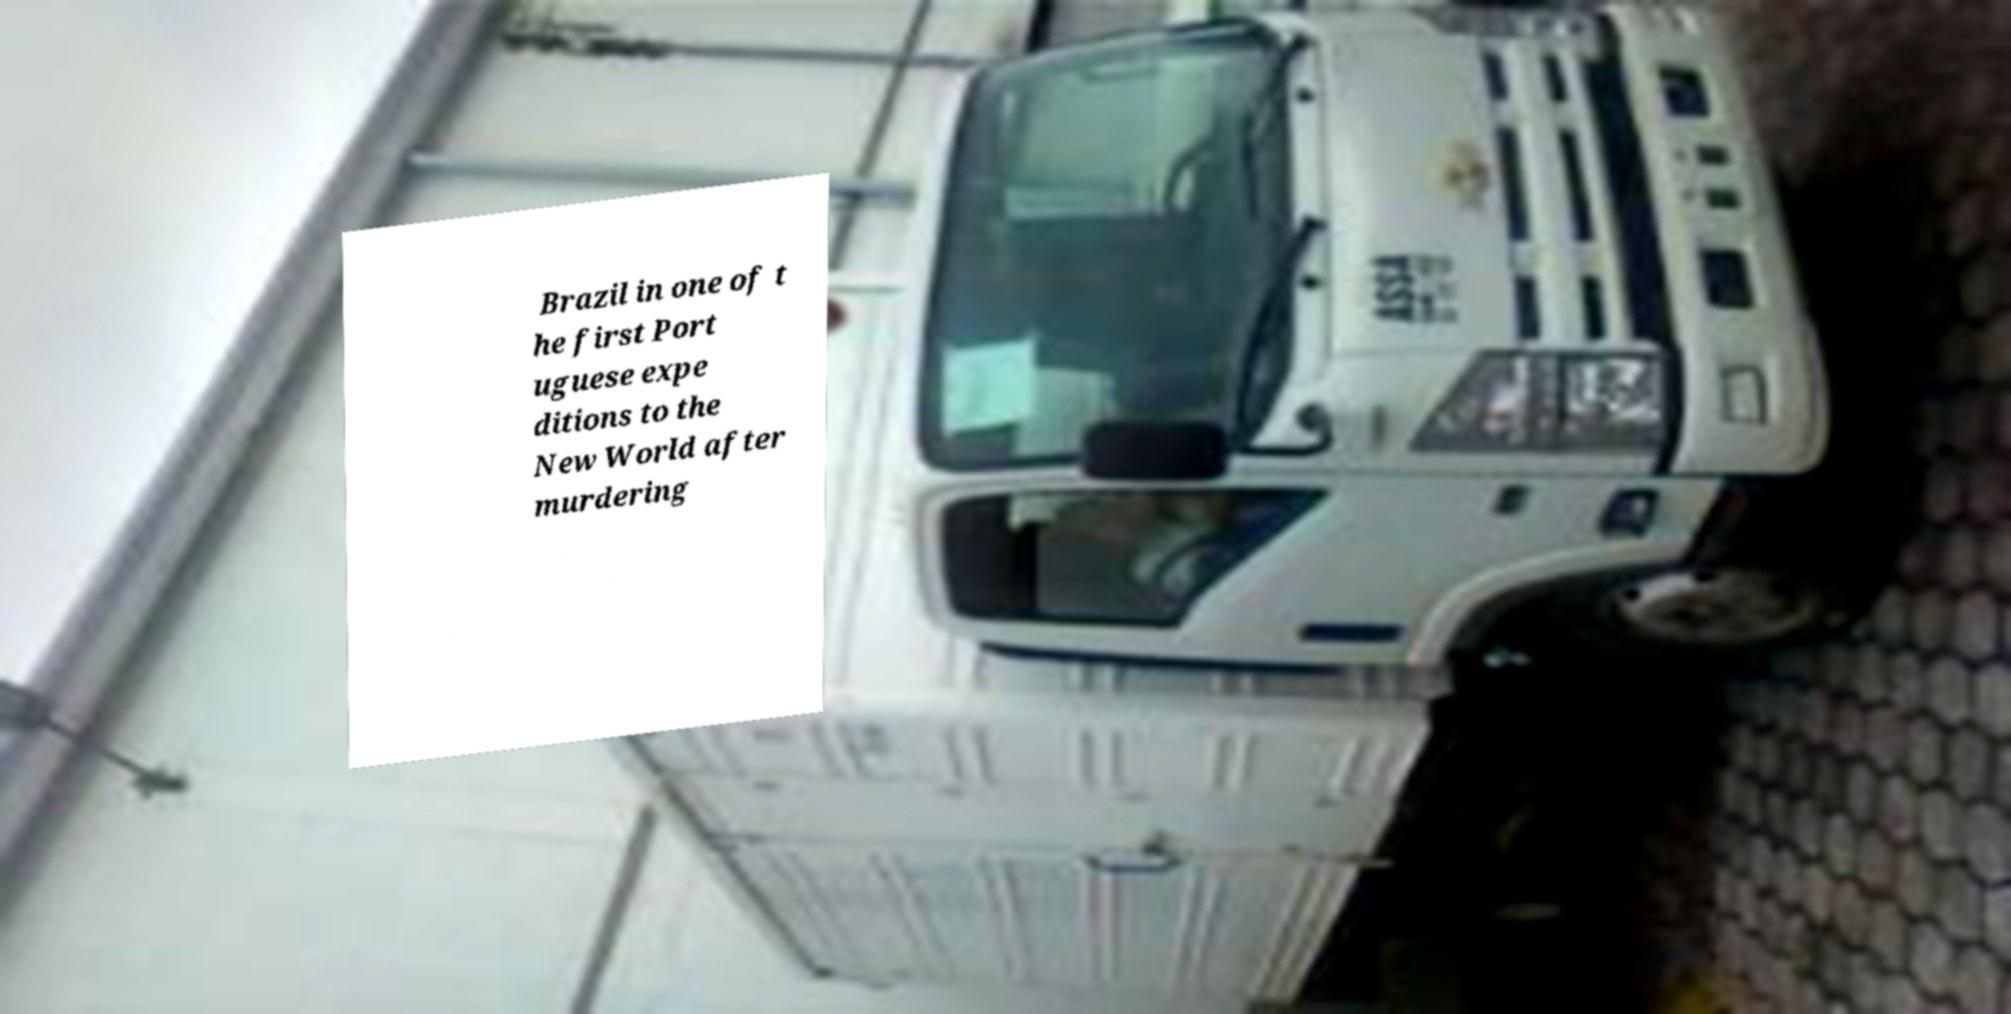Can you accurately transcribe the text from the provided image for me? Brazil in one of t he first Port uguese expe ditions to the New World after murdering 